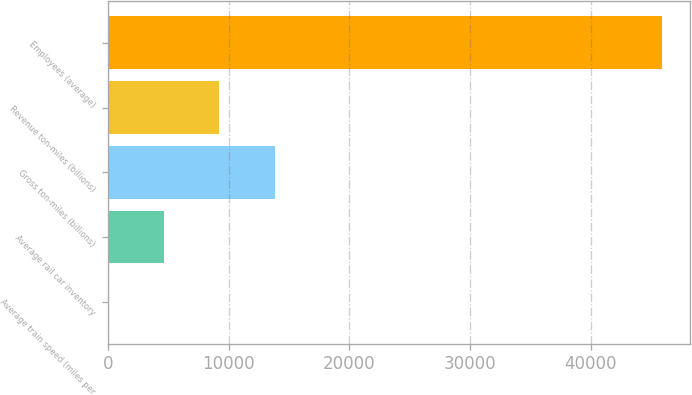<chart> <loc_0><loc_0><loc_500><loc_500><bar_chart><fcel>Average train speed (miles per<fcel>Average rail car inventory<fcel>Gross ton-miles (billions)<fcel>Revenue ton-miles (billions)<fcel>Employees (average)<nl><fcel>26.5<fcel>4616.65<fcel>13797<fcel>9206.8<fcel>45928<nl></chart> 